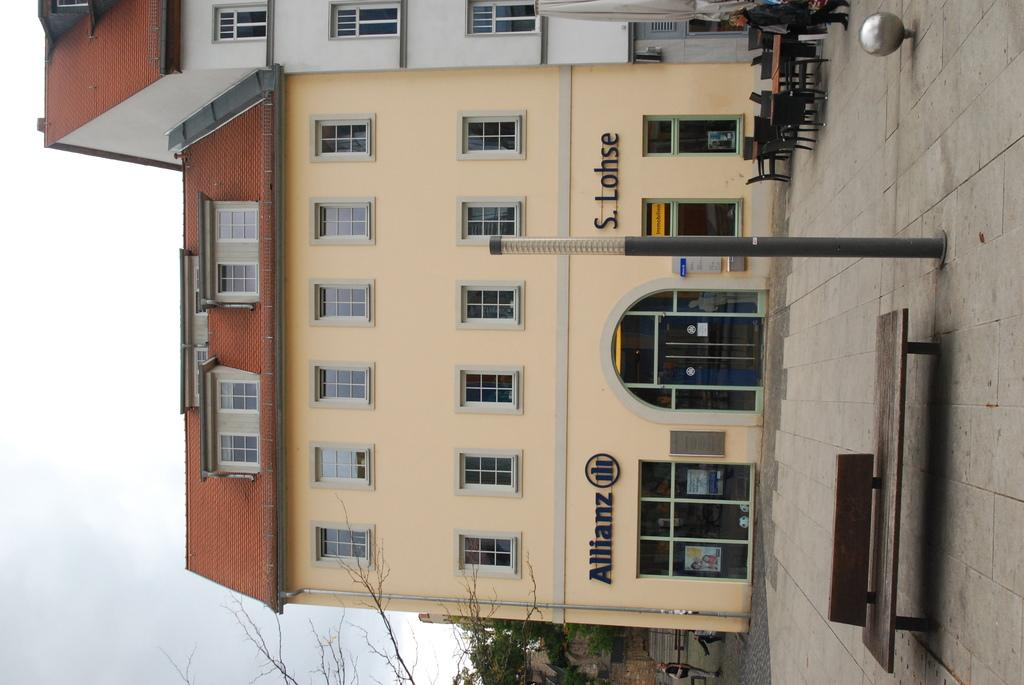<image>
Share a concise interpretation of the image provided. The outside of a yellow building which has the store Allianz. 